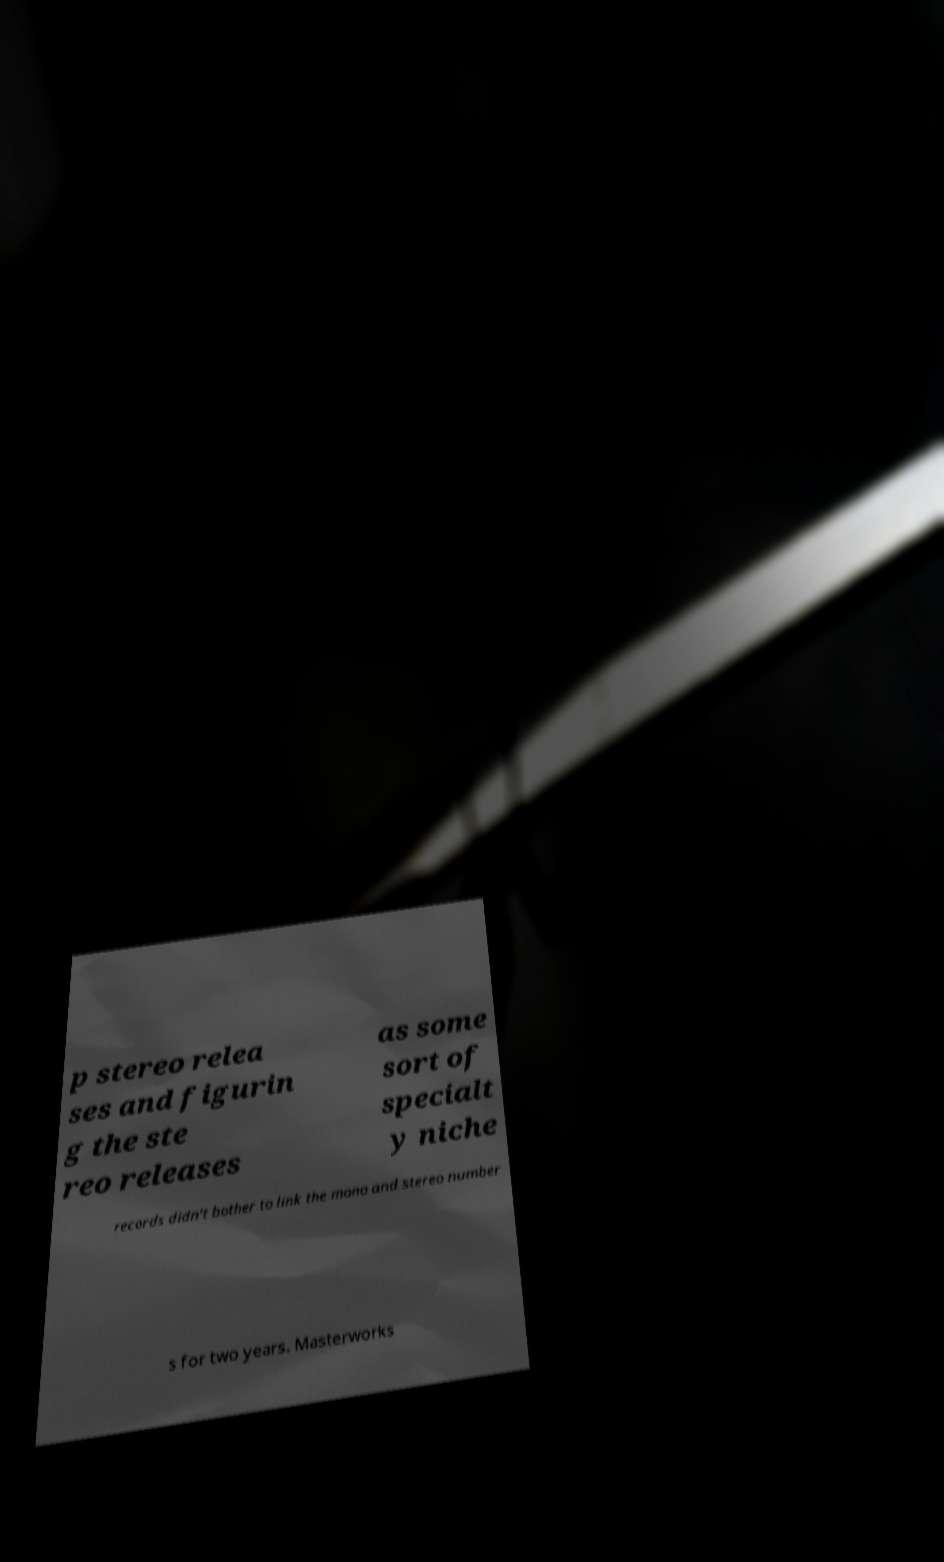There's text embedded in this image that I need extracted. Can you transcribe it verbatim? p stereo relea ses and figurin g the ste reo releases as some sort of specialt y niche records didn't bother to link the mono and stereo number s for two years. Masterworks 